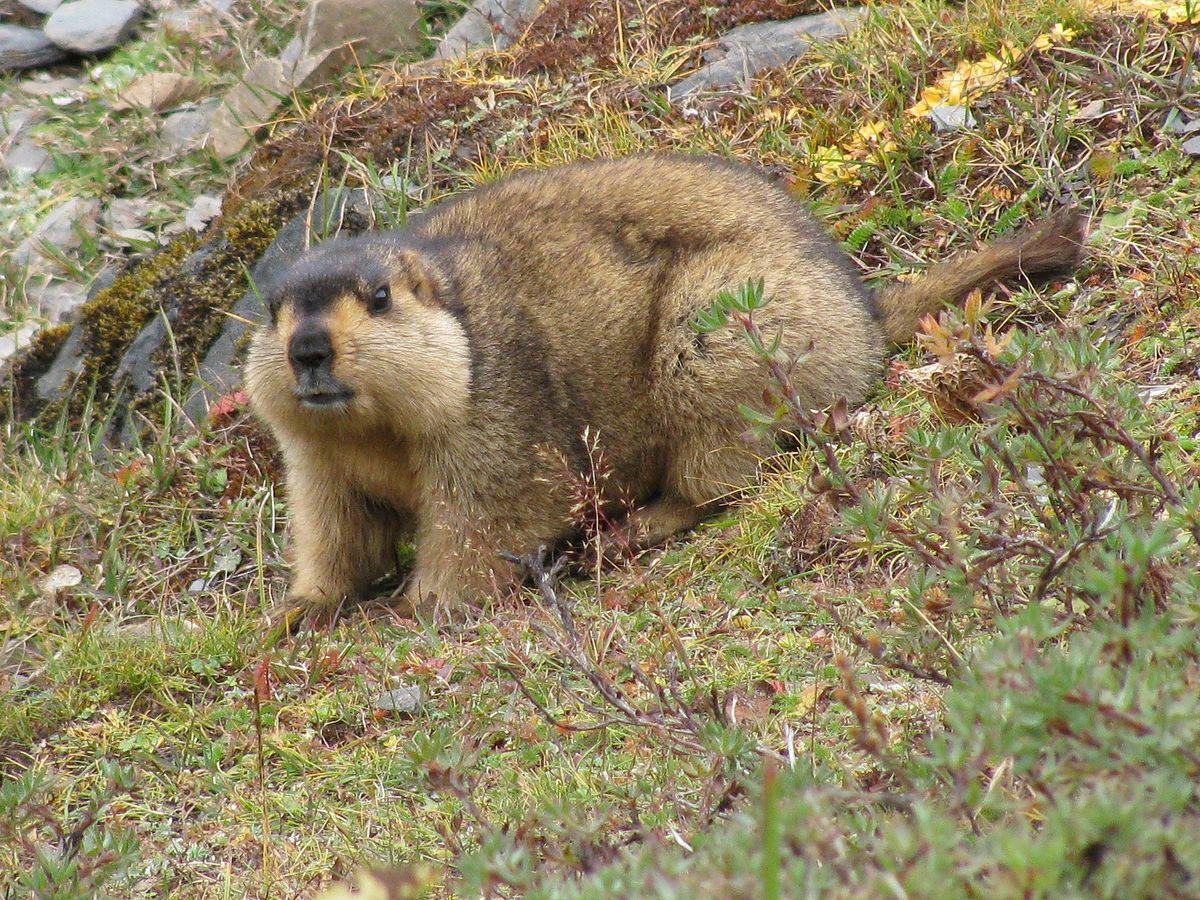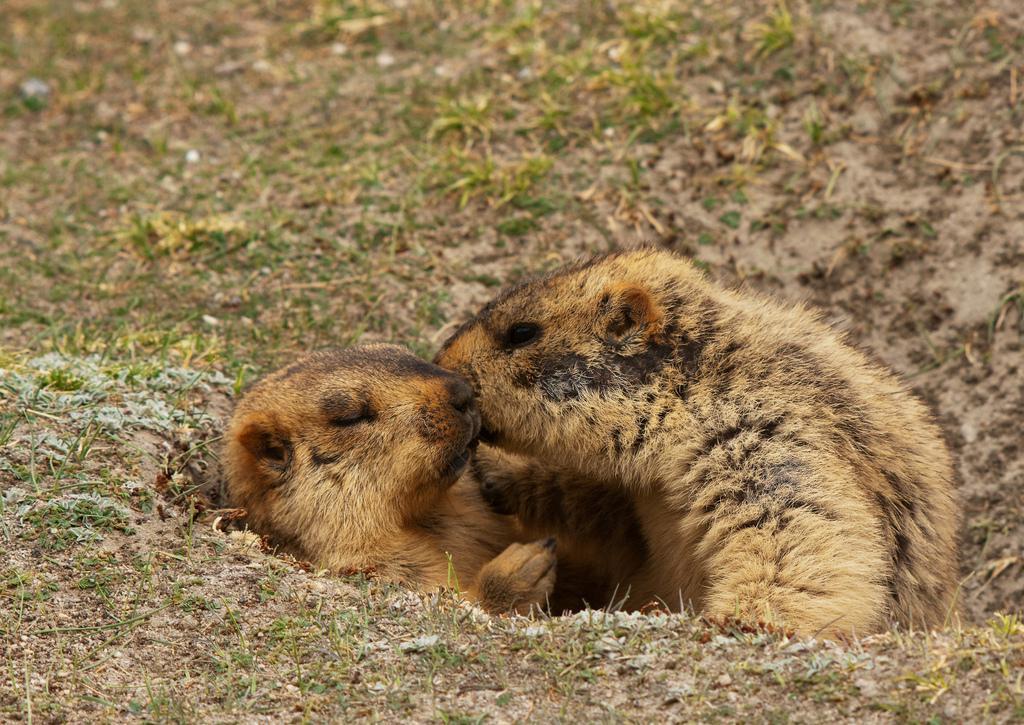The first image is the image on the left, the second image is the image on the right. Evaluate the accuracy of this statement regarding the images: "There is one gopher on the left, and two gophers being affectionate on the right.". Is it true? Answer yes or no. Yes. The first image is the image on the left, the second image is the image on the right. Evaluate the accuracy of this statement regarding the images: "At least one animal. Is standing on it's hind legs.". Is it true? Answer yes or no. No. 